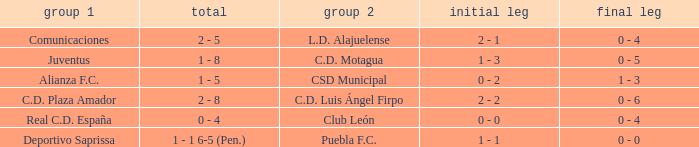What is the 1st leg where Team 1 is C.D. Plaza Amador? 2 - 2. Would you mind parsing the complete table? {'header': ['group 1', 'total', 'group 2', 'initial leg', 'final leg'], 'rows': [['Comunicaciones', '2 - 5', 'L.D. Alajuelense', '2 - 1', '0 - 4'], ['Juventus', '1 - 8', 'C.D. Motagua', '1 - 3', '0 - 5'], ['Alianza F.C.', '1 - 5', 'CSD Municipal', '0 - 2', '1 - 3'], ['C.D. Plaza Amador', '2 - 8', 'C.D. Luis Ángel Firpo', '2 - 2', '0 - 6'], ['Real C.D. España', '0 - 4', 'Club León', '0 - 0', '0 - 4'], ['Deportivo Saprissa', '1 - 1 6-5 (Pen.)', 'Puebla F.C.', '1 - 1', '0 - 0']]} 